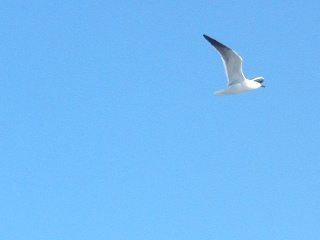Visible to the eye is a lone bird in the sky. Write a poetic verse inspired by this scene. In the ocean of sky, a lone bird glides,
Silent wings carry whispers of tides.
Beneath a sapphire dome, it soars so free,
A ballet of grace in blue serenity.
Gone are the clouds, only peace presides,
In this boundless expanse where endlessness abides. 